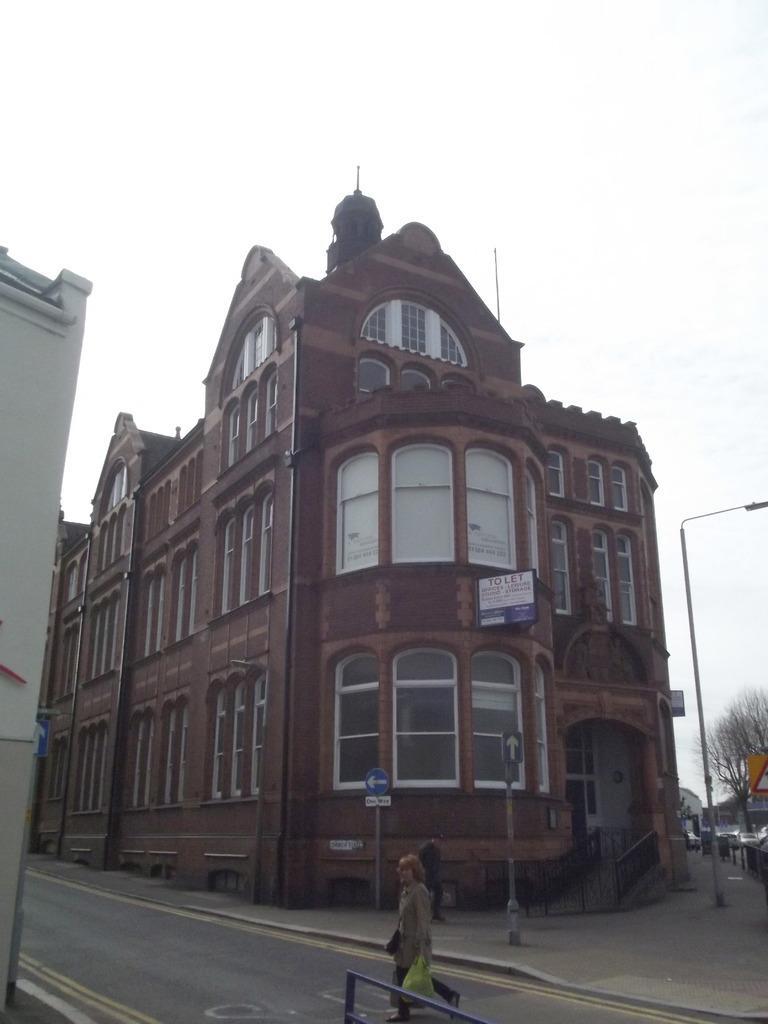Please provide a concise description of this image. In the foreground of this image, there is a person walking on the road holding a cover. In the background, there are buildings, a pole, sign board, tree and the sky. 